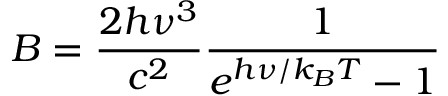Convert formula to latex. <formula><loc_0><loc_0><loc_500><loc_500>B = \frac { 2 h \nu ^ { 3 } } { c ^ { 2 } } \frac { 1 } { e ^ { h \nu / k _ { B } T } - 1 }</formula> 